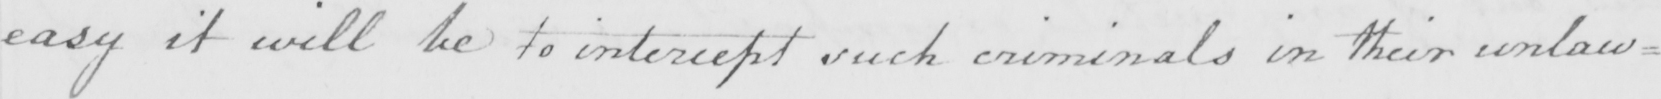Please transcribe the handwritten text in this image. easy it will be to intercept such criminals in their unlaw= 